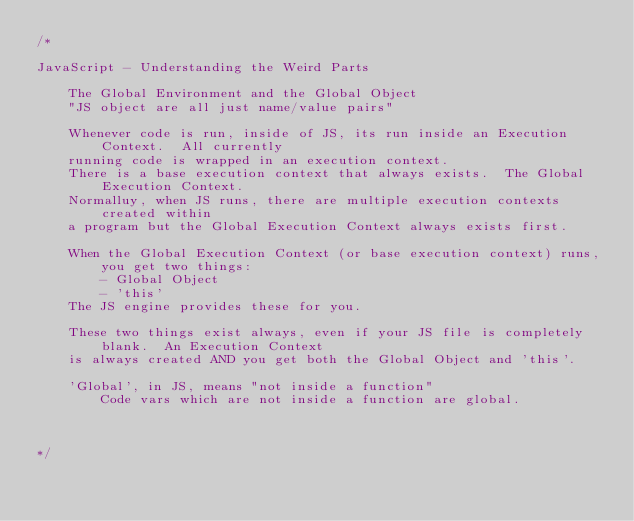<code> <loc_0><loc_0><loc_500><loc_500><_JavaScript_>/*

JavaScript - Understanding the Weird Parts

    The Global Environment and the Global Object
    "JS object are all just name/value pairs"

    Whenever code is run, inside of JS, its run inside an Execution Context.  All currently 
    running code is wrapped in an execution context.
    There is a base execution context that always exists.  The Global Execution Context.
    Normalluy, when JS runs, there are multiple execution contexts created within
    a program but the Global Execution Context always exists first.

    When the Global Execution Context (or base execution context) runs, you get two things:
        - Global Object
        - 'this'
    The JS engine provides these for you.

    These two things exist always, even if your JS file is completely blank.  An Execution Context
    is always created AND you get both the Global Object and 'this'.

    'Global', in JS, means "not inside a function"
        Code vars which are not inside a function are global.

    

*/
</code> 